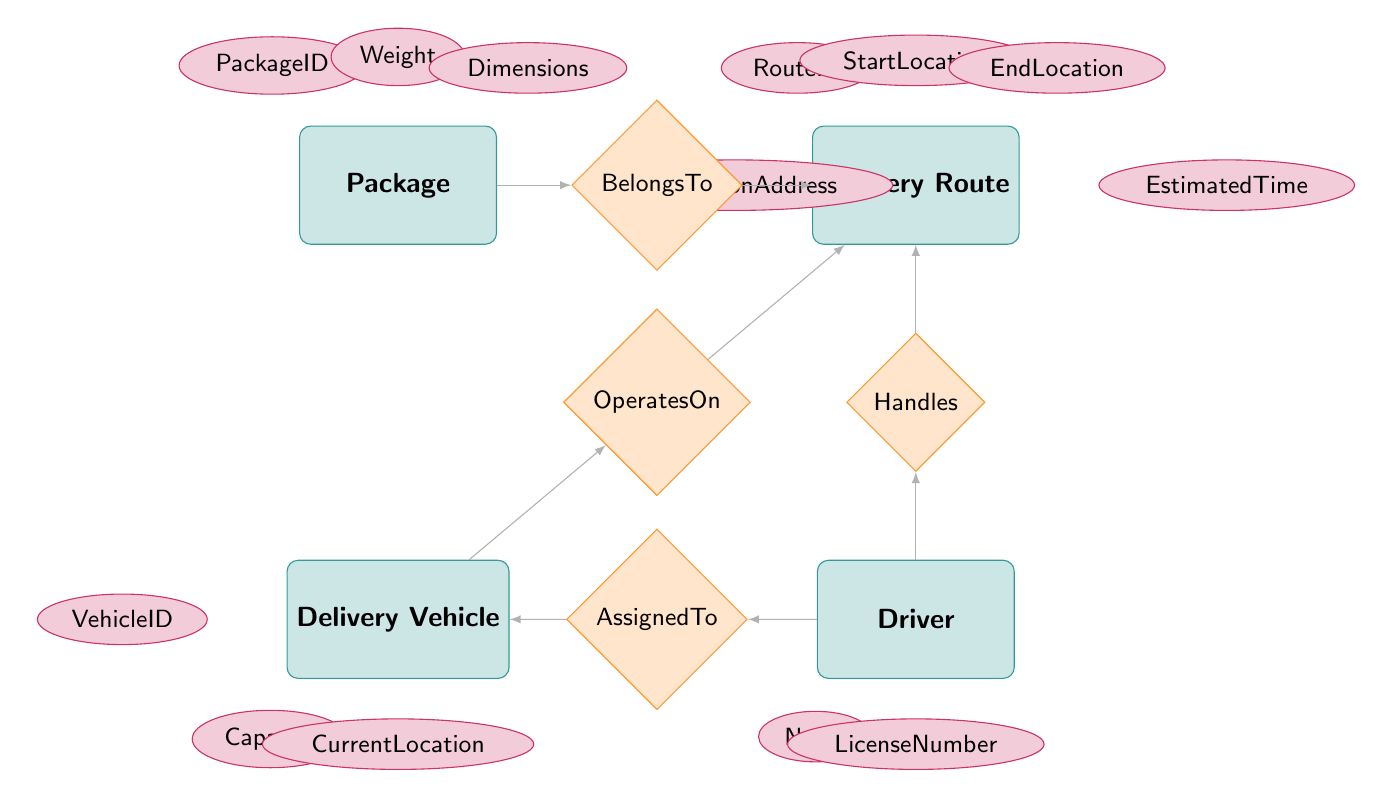What are the attributes of the Package entity? The attributes of the Package entity are listed directly connected to it in ellipses. They include PackageID, Weight, Dimensions, and DestinationAddress.
Answer: PackageID, Weight, Dimensions, DestinationAddress How many entities are in the diagram? By counting the entities in the diagram, we have four: Package, Delivery Vehicle, Driver, and Delivery Route.
Answer: 4 What relationship connects Package and Delivery Route? The relationship drawn between Package and Delivery Route is labeled as "BelongsTo," indicating that a package is associated with a delivery route.
Answer: BelongsTo Which entity has the attribute "CurrentLocation"? The attribute "CurrentLocation" is associated with the Delivery Vehicle entity, as indicated by its positioning directly below it in the diagram.
Answer: Delivery Vehicle Who operates on the Delivery Route? The Delivery Vehicle is shown to operate on the Delivery Route, as indicated by the “OperatesOn” relationship connecting the two entities.
Answer: Delivery Vehicle What attribute is shared by Driver and Delivery Vehicle entities? The Driver entity and Delivery Vehicle entity are linked through the "AssignedTo" relationship, which allows the Driver to be linked to the specific Delivery Vehicle. The shared aspect is that the Driver is assigned to operate the Delivery Vehicle.
Answer: AssignedTo What is the start location of the Delivery Route? The start location is an attribute of the Delivery Route entity, directly labeled as such in the diagram, indicating the beginning of that particular route.
Answer: StartLocation How is the Driver connected to the Delivery Route? The Driver is connected to the Delivery Route through the "Handles" relationship, which indicates that the driver manages or is responsible for the delivery route.
Answer: Handles Which entity includes Packages? The Delivery Route entity includes Packages, as indicated by the "Includes" relationship between them within the diagram.
Answer: Delivery Route 